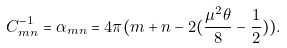<formula> <loc_0><loc_0><loc_500><loc_500>C ^ { - 1 } _ { m n } = \alpha _ { m n } = 4 \pi ( m + n - 2 ( \frac { \mu ^ { 2 } \theta } { 8 } - \frac { 1 } { 2 } ) ) .</formula> 